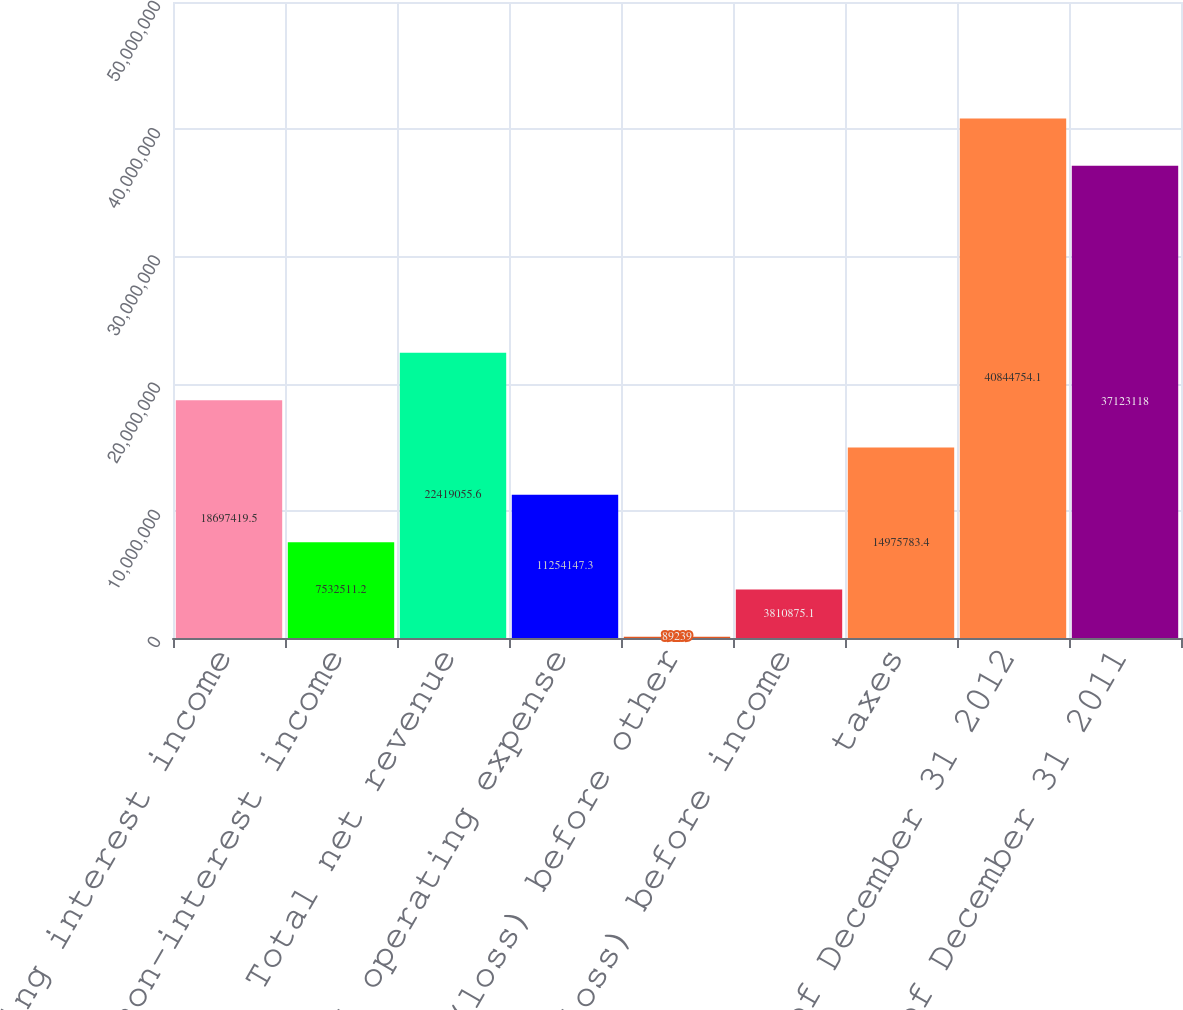Convert chart to OTSL. <chart><loc_0><loc_0><loc_500><loc_500><bar_chart><fcel>Net operating interest income<fcel>Total non-interest income<fcel>Total net revenue<fcel>Total operating expense<fcel>Income (loss) before other<fcel>Income (loss) before income<fcel>taxes<fcel>As of December 31 2012<fcel>As of December 31 2011<nl><fcel>1.86974e+07<fcel>7.53251e+06<fcel>2.24191e+07<fcel>1.12541e+07<fcel>89239<fcel>3.81088e+06<fcel>1.49758e+07<fcel>4.08448e+07<fcel>3.71231e+07<nl></chart> 